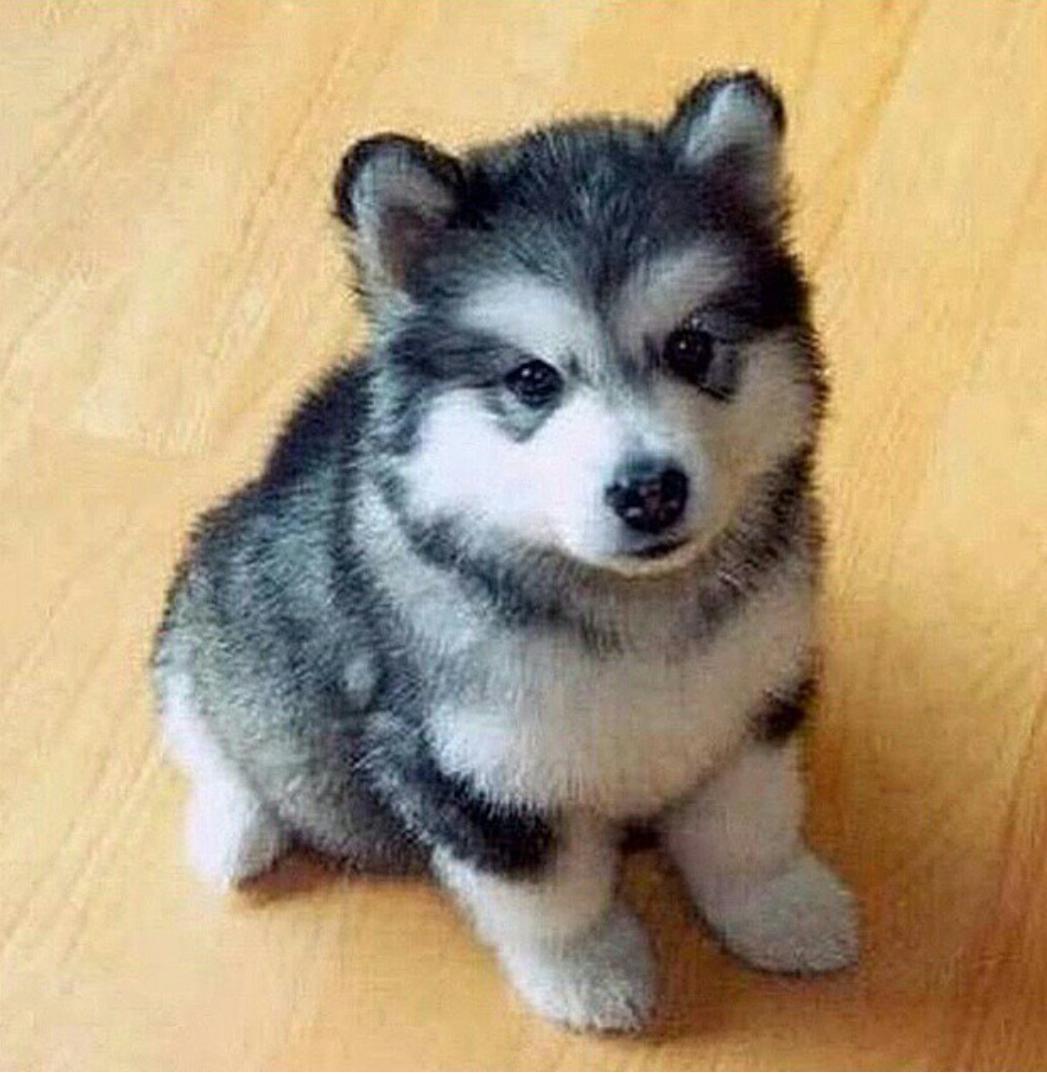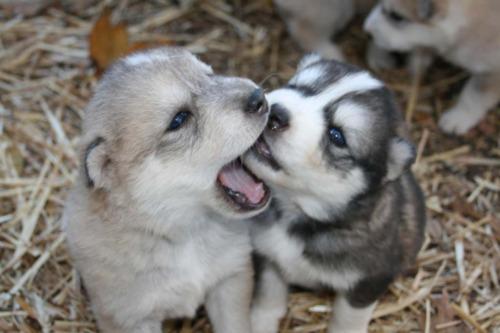The first image is the image on the left, the second image is the image on the right. Given the left and right images, does the statement "There are at most three puppies in the image pair." hold true? Answer yes or no. Yes. 